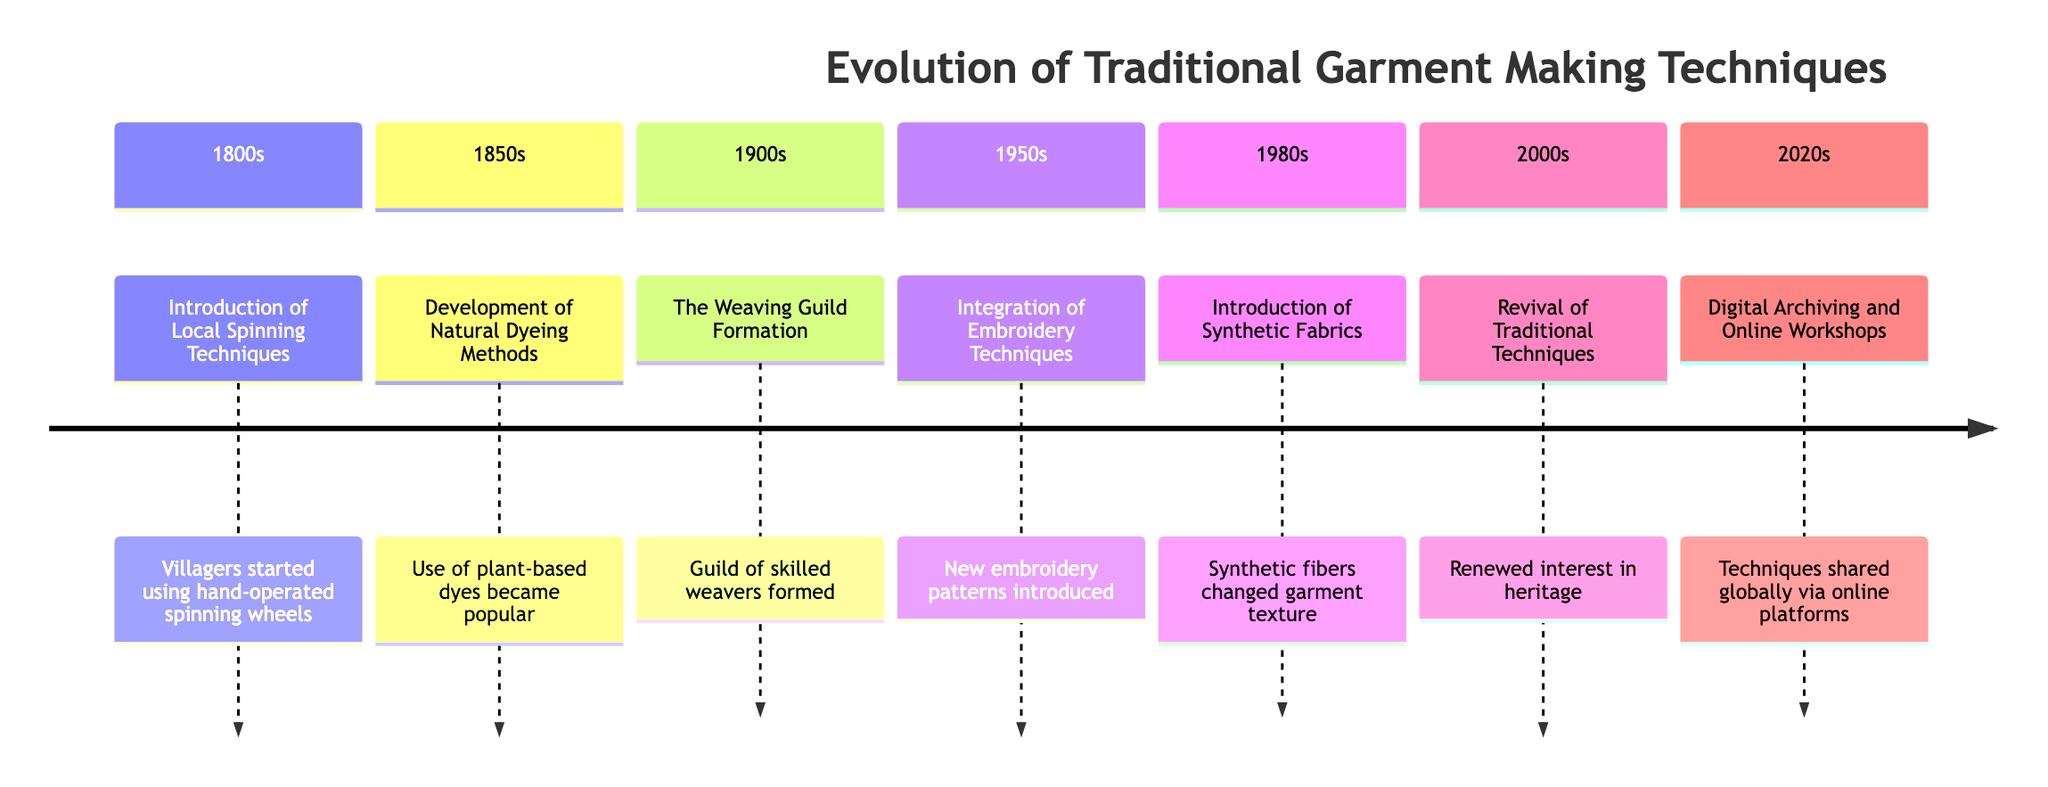What event occurred in the 1950s? The diagram specifies that in the 1950s, the integration of new embroidery techniques took place, showing the evolution of garment making during that period.
Answer: Integration of Embroidery Techniques How many periods are represented in the timeline? Counting the entries in the diagram, we see there are seven distinct periods from the 1800s to the 2020s.
Answer: 7 What technique was introduced in the 1980s? The diagram indicates that synthetic fabrics were introduced in the 1980s, marking a significant change in garment materials used in that era.
Answer: Introduction of Synthetic Fabrics Which event marked the revival of traditional techniques? According to the timeline, the revival of traditional techniques is noted as occurring in the 2000s, highlighting a resurgence of cultural heritage efforts.
Answer: Revival of Traditional Techniques What was a major change in the 2020s? In the 2020s, digital archiving and online workshops have emerged as major means of sharing and preserving traditional garment-making techniques globally.
Answer: Digital Archiving and Online Workshops Which years featured the introduction of new dyeing methods? The timeline illustrates that natural dyeing methods were developed in the 1850s, marking a key event in the evolution of garment color.
Answer: 1850s What was the purpose of forming the weaving guild in the 1900s? The formation of the weaving guild was aimed at sharing techniques and innovations in loom work, enhancing the quality of fabric production.
Answer: Sharing techniques and innovations What major material change happened in the 1980s? During the 1980s, the major change was the introduction of synthetic fibers like nylon and polyester, influencing garment texture and durability.
Answer: Synthetic fibers How did the community influence garment techniques in the 1950s? The diagram highlights that the integration of new embroidery patterns during the 1950s was influenced by neighboring communities, indicating cultural exchange.
Answer: Influenced by neighboring communities 